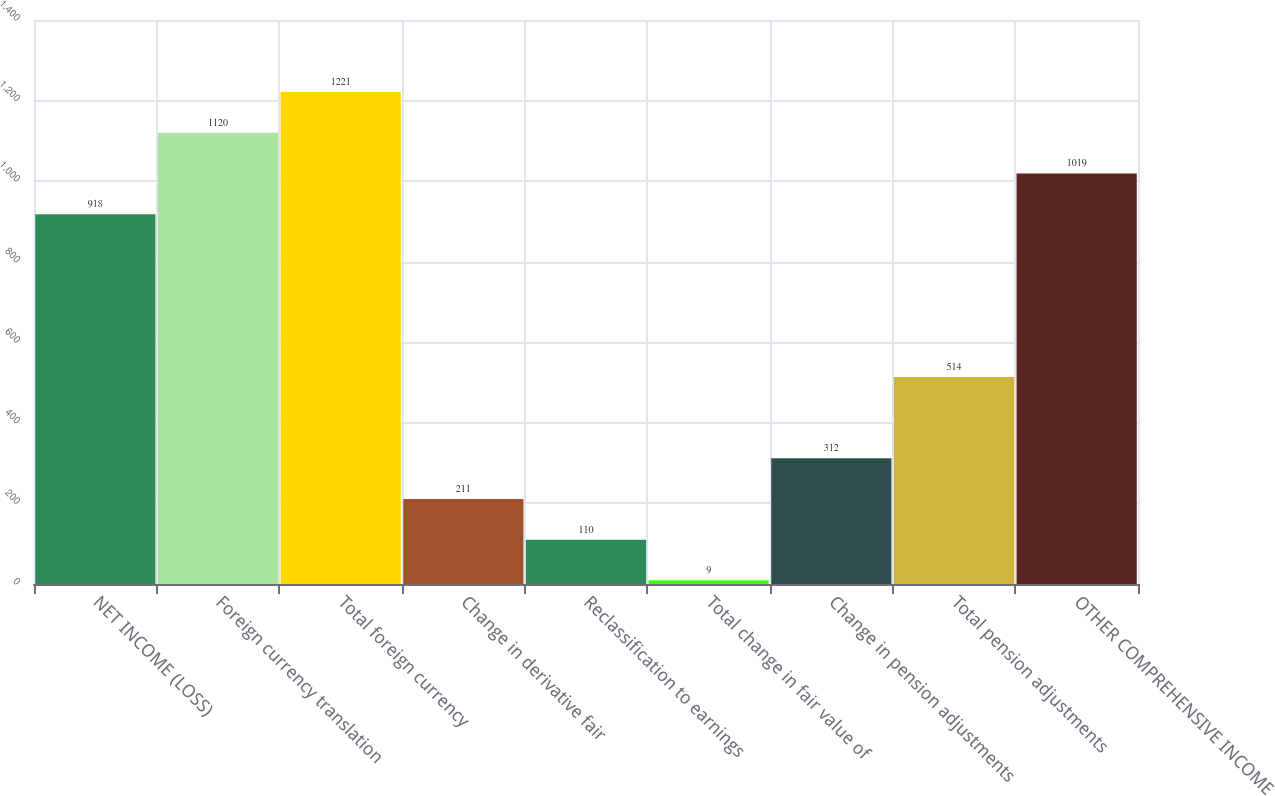<chart> <loc_0><loc_0><loc_500><loc_500><bar_chart><fcel>NET INCOME (LOSS)<fcel>Foreign currency translation<fcel>Total foreign currency<fcel>Change in derivative fair<fcel>Reclassification to earnings<fcel>Total change in fair value of<fcel>Change in pension adjustments<fcel>Total pension adjustments<fcel>OTHER COMPREHENSIVE INCOME<nl><fcel>918<fcel>1120<fcel>1221<fcel>211<fcel>110<fcel>9<fcel>312<fcel>514<fcel>1019<nl></chart> 